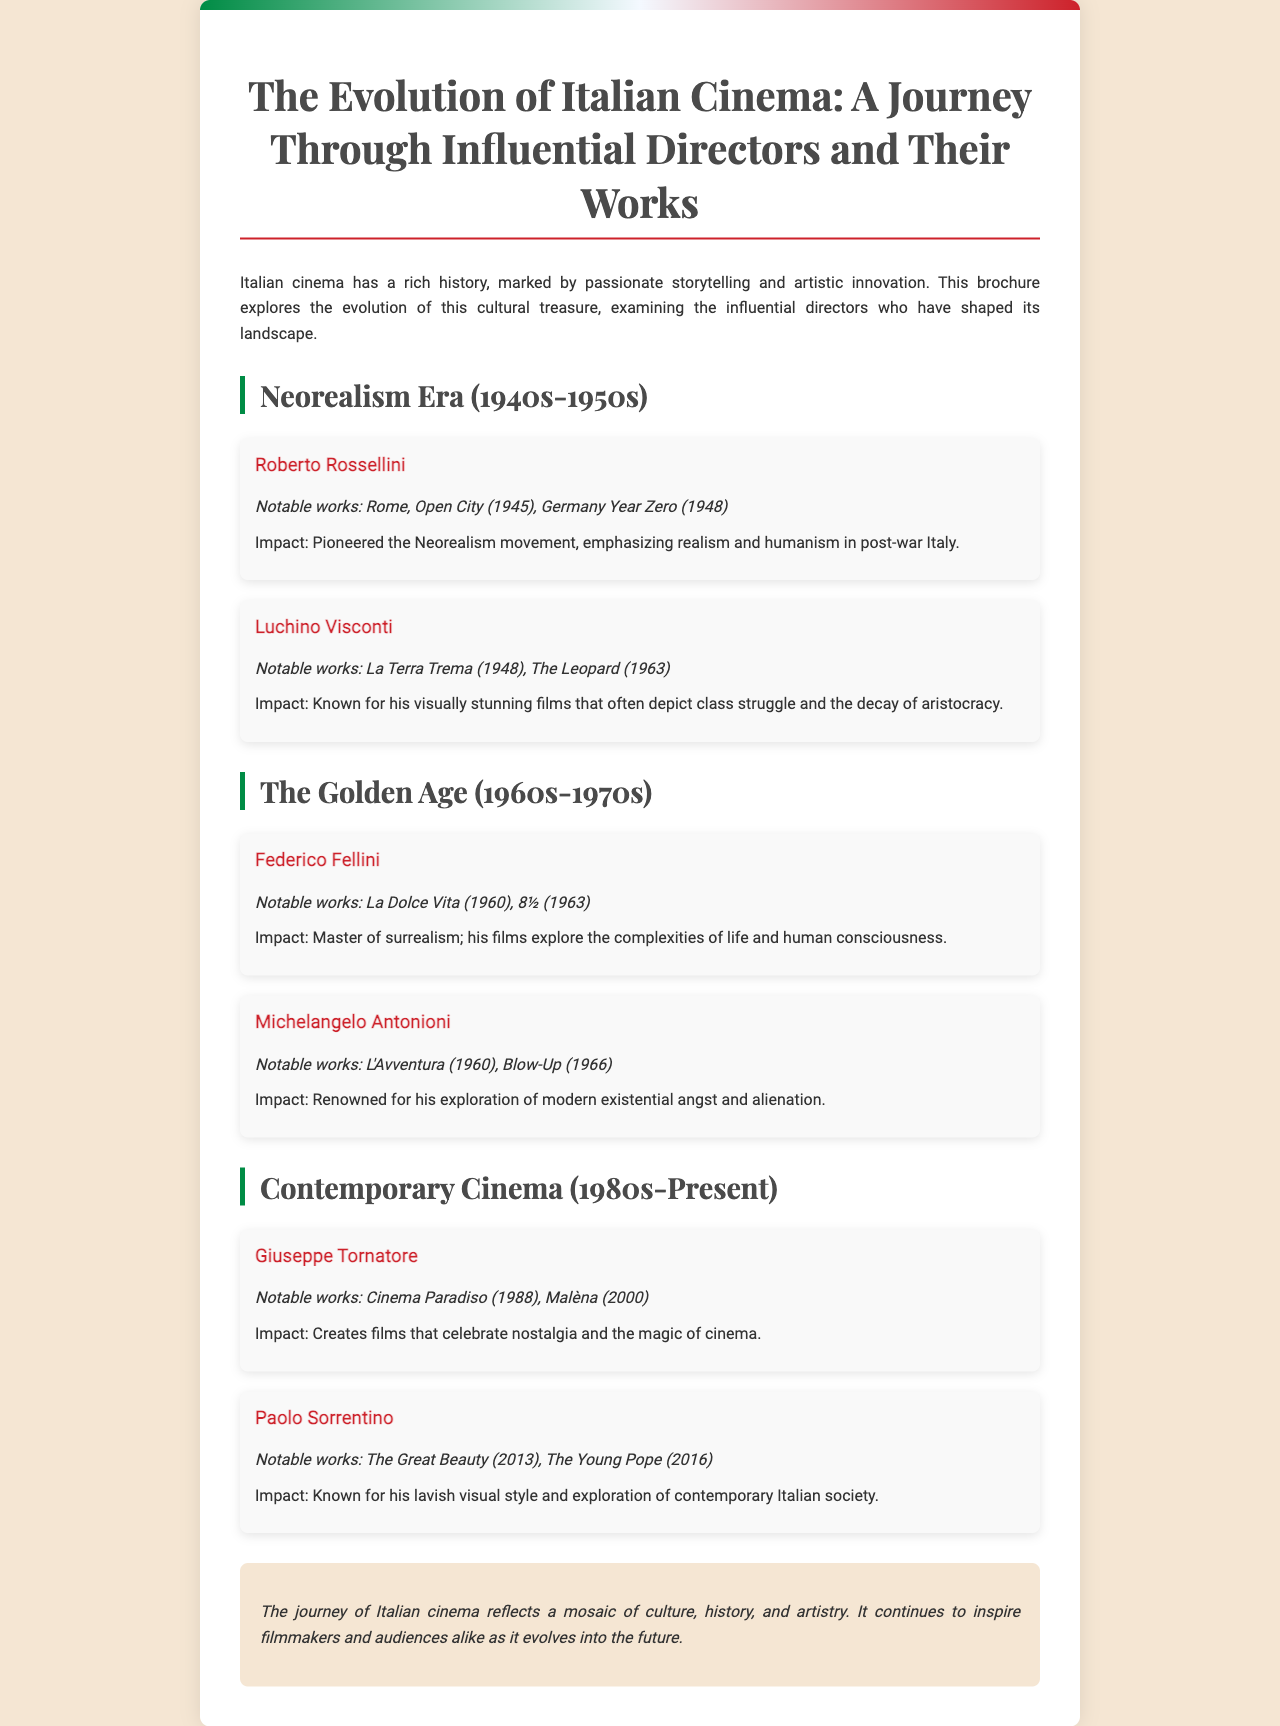What notable work is associated with Roberto Rossellini? The notable work associated with Roberto Rossellini is mentioned in the document as "Rome, Open City (1945)".
Answer: Rome, Open City (1945) Which era does Federico Fellini belong to? The era in which Federico Fellini is placed is specified in the document as "The Golden Age (1960s-1970s)".
Answer: The Golden Age (1960s-1970s) What is the impact of Luchino Visconti's films? The document states that Luchino Visconti is known for films depicting "class struggle and the decay of aristocracy".
Answer: Class struggle and the decay of aristocracy Which director is known for the film "Cinema Paradiso"? The director associated with "Cinema Paradiso" is identified in the document as Giuseppe Tornatore.
Answer: Giuseppe Tornatore What notable work does Paolo Sorrentino have? The document lists "The Great Beauty (2013)" as a notable work of Paolo Sorrentino.
Answer: The Great Beauty (2013) Which film is recognized as a hallmark of Neorealism? The document presents "Rome, Open City (1945)" as a hallmark of the Neorealism movement.
Answer: Rome, Open City (1945) What theme do Giuseppe Tornatore's films often celebrate? The document mentions that Giuseppe Tornatore's films celebrate "nostalgia and the magic of cinema".
Answer: Nostalgia and the magic of cinema How many directors are highlighted in the brochure? The total number of directors mentioned in the document is counted as five, as they are all listed under different sections.
Answer: Five 